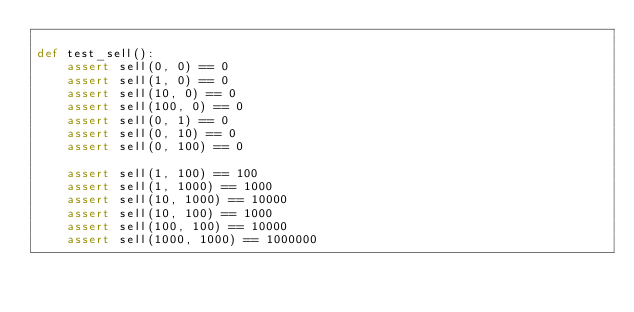<code> <loc_0><loc_0><loc_500><loc_500><_Python_>
def test_sell():
    assert sell(0, 0) == 0
    assert sell(1, 0) == 0
    assert sell(10, 0) == 0
    assert sell(100, 0) == 0
    assert sell(0, 1) == 0
    assert sell(0, 10) == 0
    assert sell(0, 100) == 0

    assert sell(1, 100) == 100
    assert sell(1, 1000) == 1000
    assert sell(10, 1000) == 10000
    assert sell(10, 100) == 1000
    assert sell(100, 100) == 10000
    assert sell(1000, 1000) == 1000000</code> 